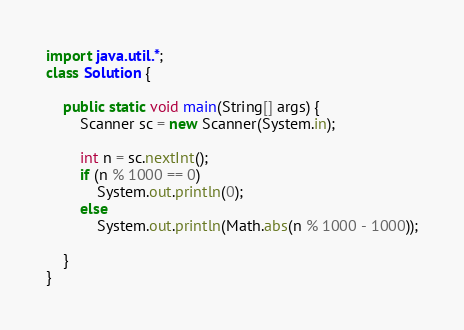<code> <loc_0><loc_0><loc_500><loc_500><_Java_>import java.util.*;
class Solution {

    public static void main(String[] args) {
        Scanner sc = new Scanner(System.in);

        int n = sc.nextInt();
        if (n % 1000 == 0)
            System.out.println(0);
        else 
            System.out.println(Math.abs(n % 1000 - 1000));

    }
}</code> 